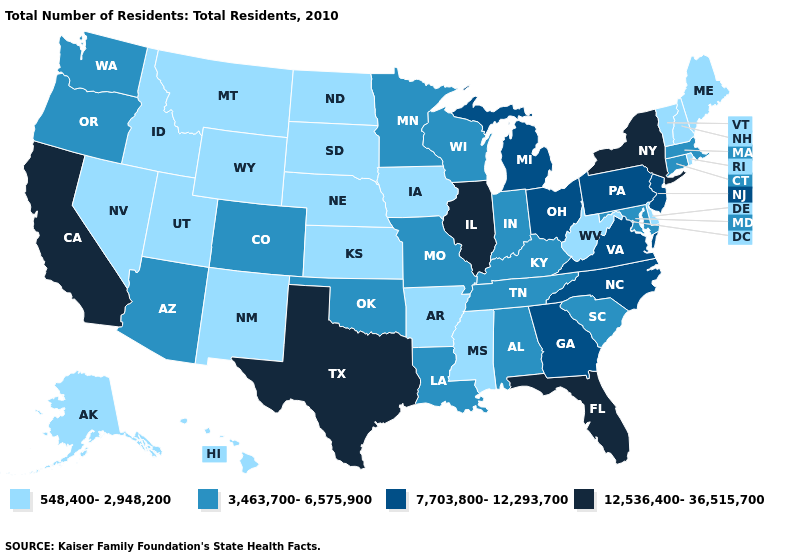Does Tennessee have the same value as Minnesota?
Give a very brief answer. Yes. Does Minnesota have a higher value than Rhode Island?
Be succinct. Yes. Which states have the lowest value in the Northeast?
Short answer required. Maine, New Hampshire, Rhode Island, Vermont. Name the states that have a value in the range 7,703,800-12,293,700?
Keep it brief. Georgia, Michigan, New Jersey, North Carolina, Ohio, Pennsylvania, Virginia. Name the states that have a value in the range 548,400-2,948,200?
Give a very brief answer. Alaska, Arkansas, Delaware, Hawaii, Idaho, Iowa, Kansas, Maine, Mississippi, Montana, Nebraska, Nevada, New Hampshire, New Mexico, North Dakota, Rhode Island, South Dakota, Utah, Vermont, West Virginia, Wyoming. What is the value of Kentucky?
Keep it brief. 3,463,700-6,575,900. What is the value of Virginia?
Keep it brief. 7,703,800-12,293,700. Does Illinois have the highest value in the USA?
Answer briefly. Yes. Does Washington have the lowest value in the West?
Write a very short answer. No. Name the states that have a value in the range 3,463,700-6,575,900?
Keep it brief. Alabama, Arizona, Colorado, Connecticut, Indiana, Kentucky, Louisiana, Maryland, Massachusetts, Minnesota, Missouri, Oklahoma, Oregon, South Carolina, Tennessee, Washington, Wisconsin. What is the value of Alabama?
Quick response, please. 3,463,700-6,575,900. Does Arizona have a higher value than Connecticut?
Give a very brief answer. No. Does New York have the highest value in the USA?
Answer briefly. Yes. What is the highest value in the USA?
Give a very brief answer. 12,536,400-36,515,700. Name the states that have a value in the range 548,400-2,948,200?
Quick response, please. Alaska, Arkansas, Delaware, Hawaii, Idaho, Iowa, Kansas, Maine, Mississippi, Montana, Nebraska, Nevada, New Hampshire, New Mexico, North Dakota, Rhode Island, South Dakota, Utah, Vermont, West Virginia, Wyoming. 